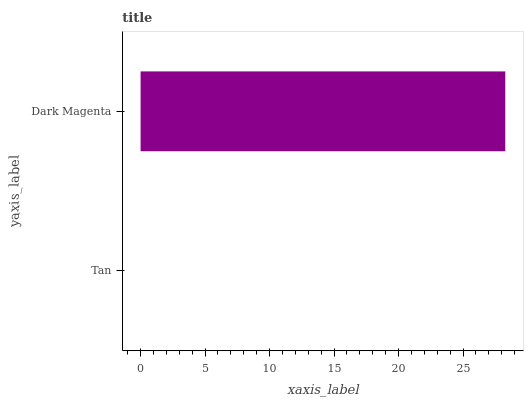Is Tan the minimum?
Answer yes or no. Yes. Is Dark Magenta the maximum?
Answer yes or no. Yes. Is Dark Magenta the minimum?
Answer yes or no. No. Is Dark Magenta greater than Tan?
Answer yes or no. Yes. Is Tan less than Dark Magenta?
Answer yes or no. Yes. Is Tan greater than Dark Magenta?
Answer yes or no. No. Is Dark Magenta less than Tan?
Answer yes or no. No. Is Dark Magenta the high median?
Answer yes or no. Yes. Is Tan the low median?
Answer yes or no. Yes. Is Tan the high median?
Answer yes or no. No. Is Dark Magenta the low median?
Answer yes or no. No. 